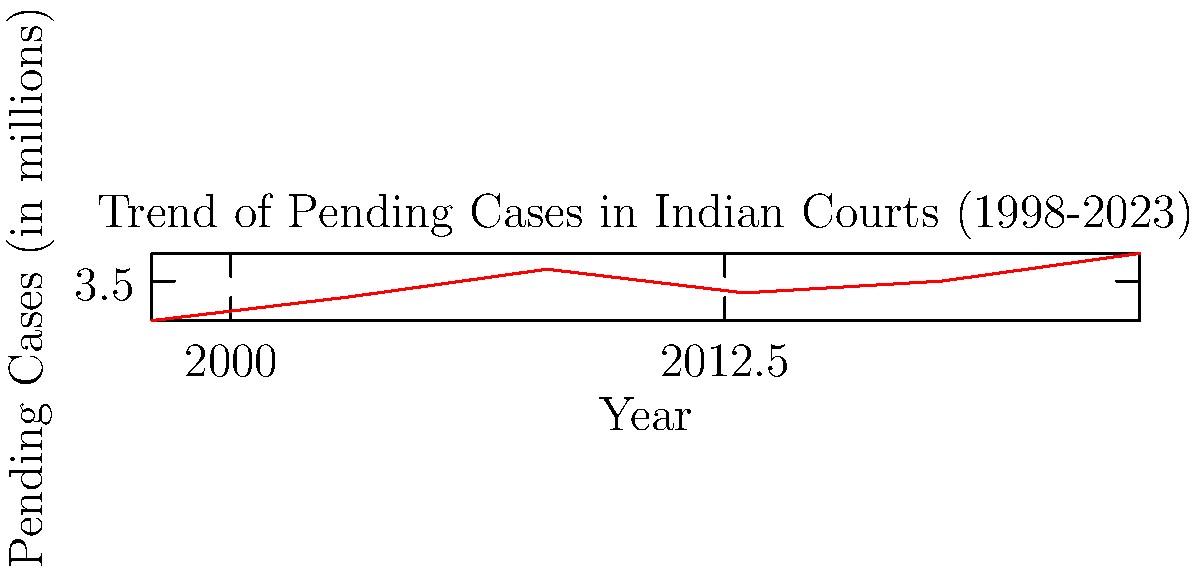Based on the line graph showing the trend of pending cases in Indian courts over the past 25 years, what can be inferred about the efficiency of the Indian judicial system in clearing case backlogs? To answer this question, we need to analyze the trend in the graph:

1. Starting point (1998): The graph shows approximately 2.5 million pending cases.

2. Trend from 1998 to 2008: There is a steady increase in pending cases from about 2.5 million to 3.8 million over this 10-year period.

3. Period from 2008 to 2013: There's a notable decrease in pending cases from 3.8 million to about 3.2 million.

4. Trend from 2013 to 2023: The number of pending cases rises again, reaching about 4.2 million by 2023.

5. Overall trend: Despite some fluctuations, there is a general upward trend in the number of pending cases over the 25-year period.

6. Rate of increase: The rate of increase appears to be faster in recent years (2013-2023) compared to the earlier period (1998-2008).

Given these observations, we can infer that the Indian judicial system has struggled to effectively clear case backlogs over the past 25 years. While there was a period of improvement (2008-2013), the system has not been able to sustain this progress, and the backlog has continued to grow, particularly in recent years.

This trend suggests that the efficiency of the Indian judicial system in clearing case backlogs has not significantly improved over the 25-year period, and in fact, the challenge of pending cases has worsened in recent years.
Answer: The efficiency has not improved significantly; case backlogs have generally increased over 25 years, indicating persistent challenges in the Indian judicial system. 